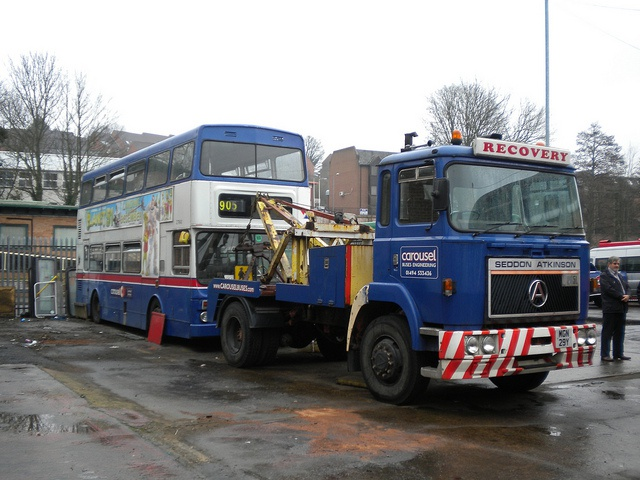Describe the objects in this image and their specific colors. I can see truck in white, black, navy, gray, and darkgray tones, bus in white, gray, darkgray, navy, and black tones, and people in white, black, gray, and darkgray tones in this image. 